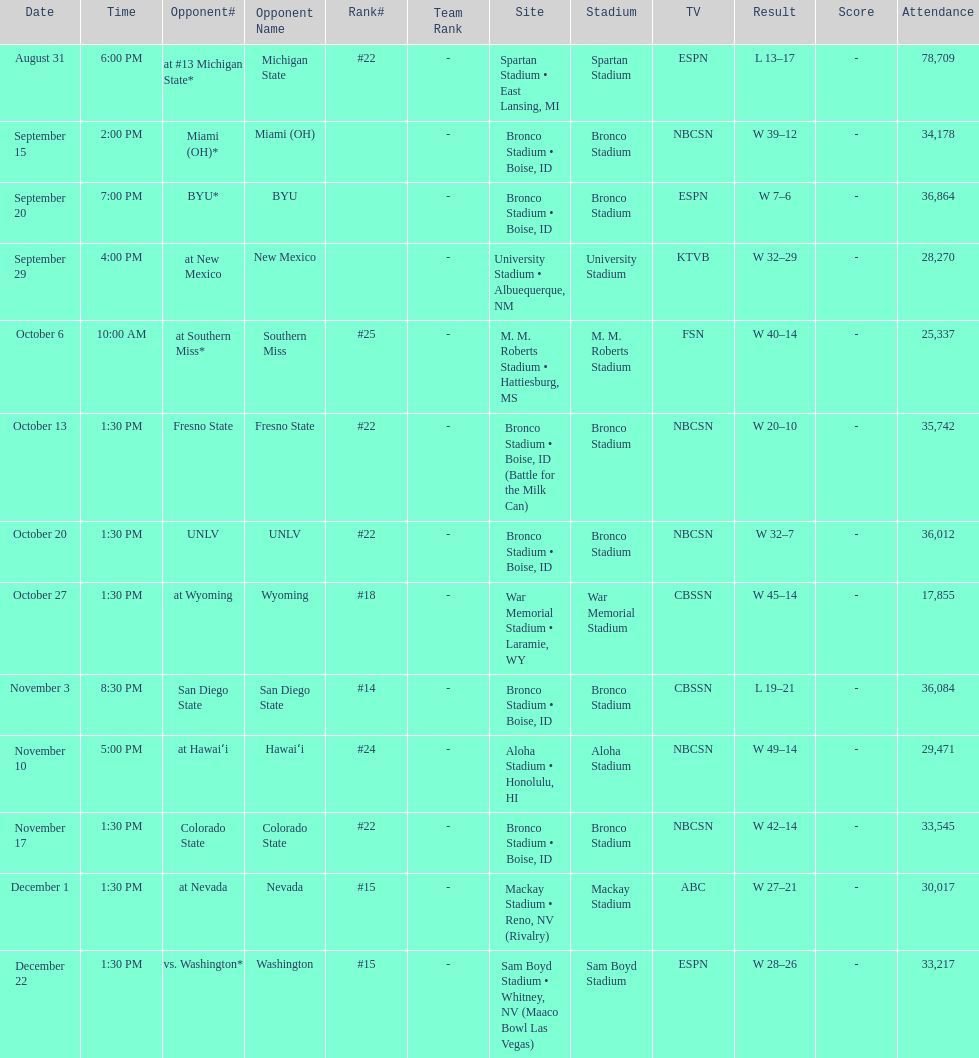What rank was boise state after november 10th? #22. Would you be able to parse every entry in this table? {'header': ['Date', 'Time', 'Opponent#', 'Opponent Name', 'Rank#', 'Team Rank', 'Site', 'Stadium', 'TV', 'Result', 'Score', 'Attendance'], 'rows': [['August 31', '6:00 PM', 'at\xa0#13\xa0Michigan State*', 'Michigan State', '#22', '-', 'Spartan Stadium • East Lansing, MI', 'Spartan Stadium', 'ESPN', 'L\xa013–17', '-', '78,709'], ['September 15', '2:00 PM', 'Miami (OH)*', 'Miami (OH)', '', '-', 'Bronco Stadium • Boise, ID', 'Bronco Stadium', 'NBCSN', 'W\xa039–12', '-', '34,178'], ['September 20', '7:00 PM', 'BYU*', 'BYU', '', '-', 'Bronco Stadium • Boise, ID', 'Bronco Stadium', 'ESPN', 'W\xa07–6', '-', '36,864'], ['September 29', '4:00 PM', 'at\xa0New Mexico', 'New Mexico', '', '-', 'University Stadium • Albuequerque, NM', 'University Stadium', 'KTVB', 'W\xa032–29', '-', '28,270'], ['October 6', '10:00 AM', 'at\xa0Southern Miss*', 'Southern Miss', '#25', '-', 'M. M. Roberts Stadium • Hattiesburg, MS', 'M. M. Roberts Stadium', 'FSN', 'W\xa040–14', '-', '25,337'], ['October 13', '1:30 PM', 'Fresno State', 'Fresno State', '#22', '-', 'Bronco Stadium • Boise, ID (Battle for the Milk Can)', 'Bronco Stadium', 'NBCSN', 'W\xa020–10', '-', '35,742'], ['October 20', '1:30 PM', 'UNLV', 'UNLV', '#22', '-', 'Bronco Stadium • Boise, ID', 'Bronco Stadium', 'NBCSN', 'W\xa032–7', '-', '36,012'], ['October 27', '1:30 PM', 'at\xa0Wyoming', 'Wyoming', '#18', '-', 'War Memorial Stadium • Laramie, WY', 'War Memorial Stadium', 'CBSSN', 'W\xa045–14', '-', '17,855'], ['November 3', '8:30 PM', 'San Diego State', 'San Diego State', '#14', '-', 'Bronco Stadium • Boise, ID', 'Bronco Stadium', 'CBSSN', 'L\xa019–21', '-', '36,084'], ['November 10', '5:00 PM', 'at\xa0Hawaiʻi', 'Hawaiʻi', '#24', '-', 'Aloha Stadium • Honolulu, HI', 'Aloha Stadium', 'NBCSN', 'W\xa049–14', '-', '29,471'], ['November 17', '1:30 PM', 'Colorado State', 'Colorado State', '#22', '-', 'Bronco Stadium • Boise, ID', 'Bronco Stadium', 'NBCSN', 'W\xa042–14', '-', '33,545'], ['December 1', '1:30 PM', 'at\xa0Nevada', 'Nevada', '#15', '-', 'Mackay Stadium • Reno, NV (Rivalry)', 'Mackay Stadium', 'ABC', 'W\xa027–21', '-', '30,017'], ['December 22', '1:30 PM', 'vs.\xa0Washington*', 'Washington', '#15', '-', 'Sam Boyd Stadium • Whitney, NV (Maaco Bowl Las Vegas)', 'Sam Boyd Stadium', 'ESPN', 'W\xa028–26', '-', '33,217']]} 